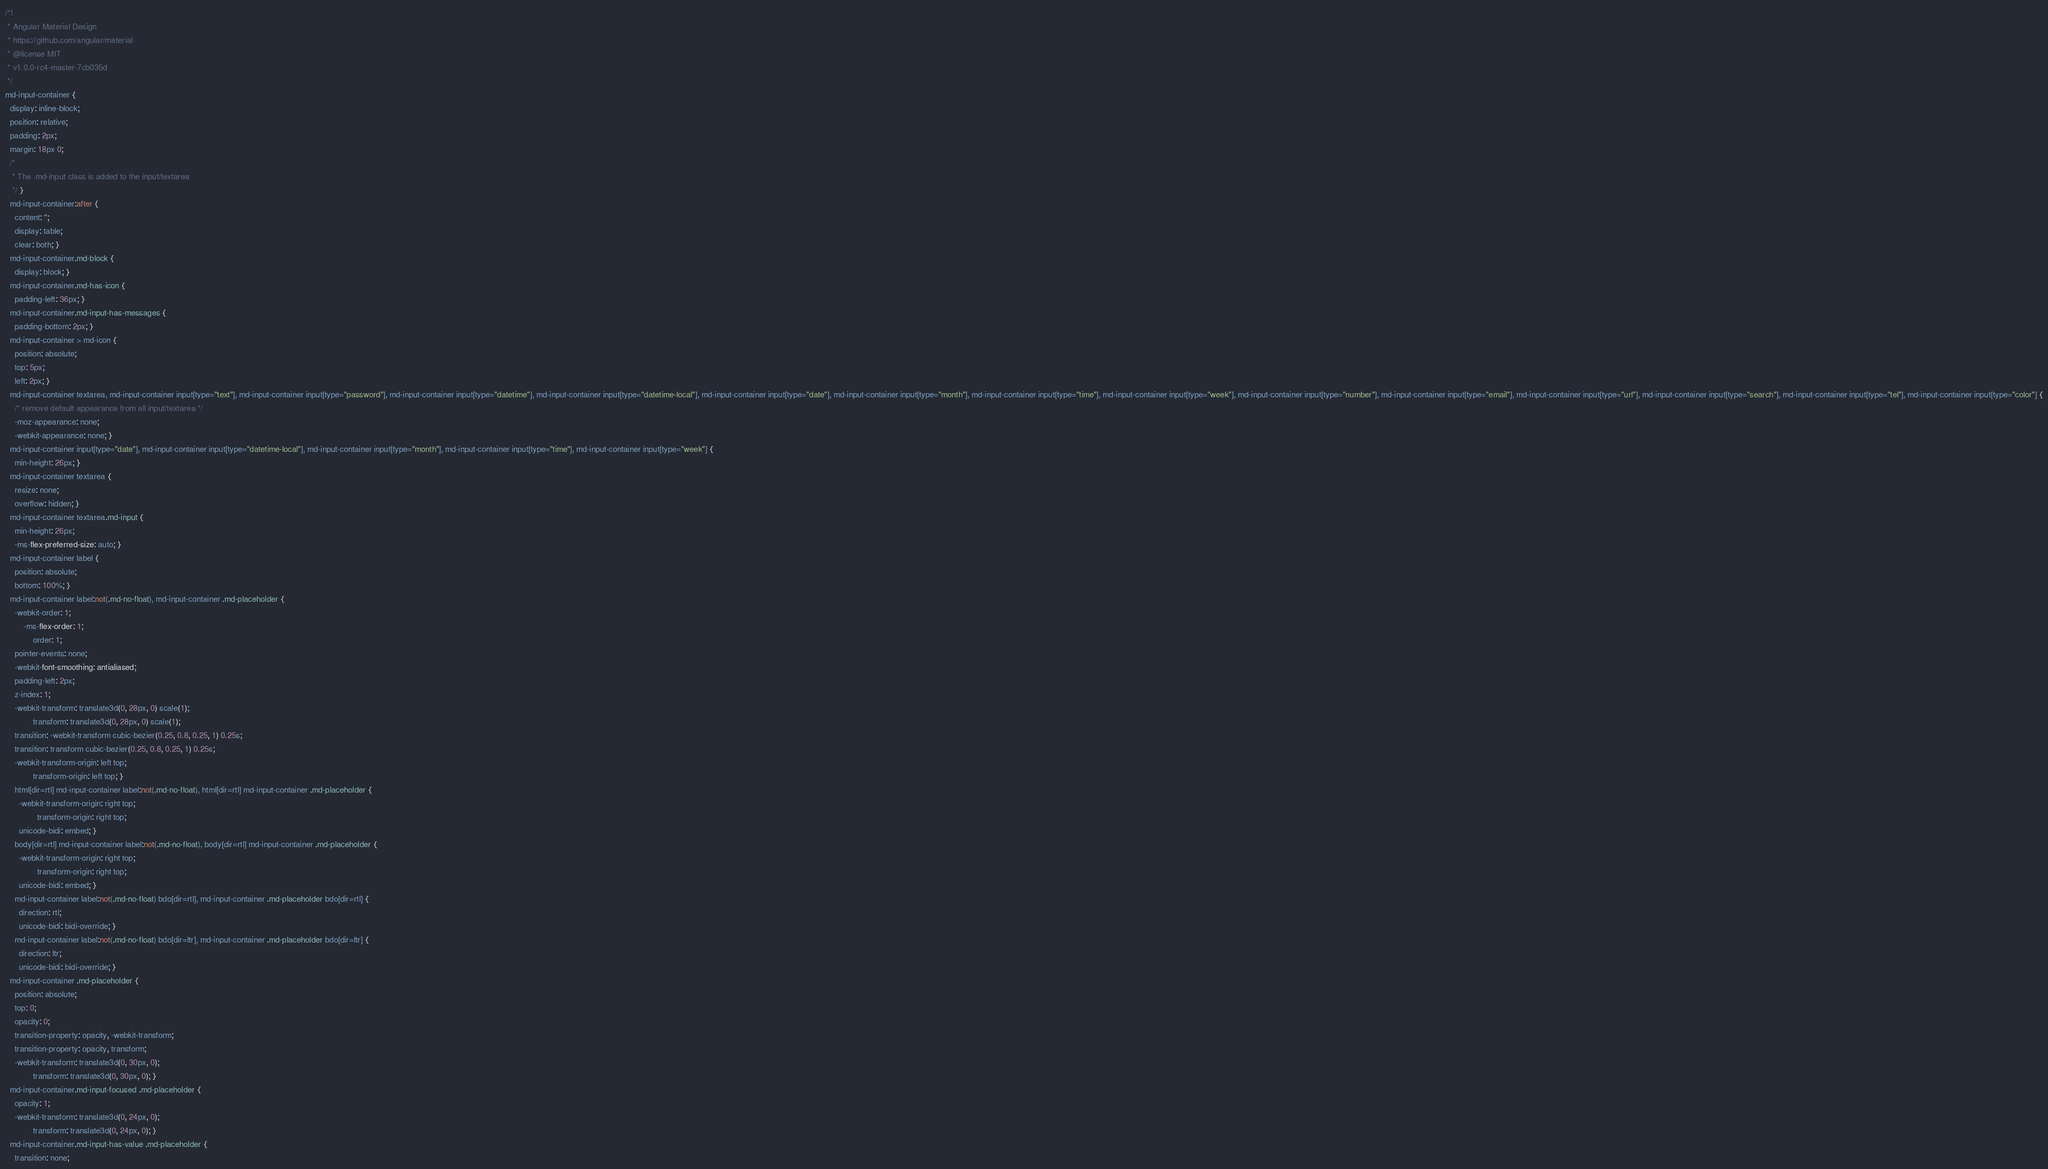<code> <loc_0><loc_0><loc_500><loc_500><_CSS_>/*!
 * Angular Material Design
 * https://github.com/angular/material
 * @license MIT
 * v1.0.0-rc4-master-7cb035d
 */
md-input-container {
  display: inline-block;
  position: relative;
  padding: 2px;
  margin: 18px 0;
  /*
   * The .md-input class is added to the input/textarea
   */ }
  md-input-container:after {
    content: '';
    display: table;
    clear: both; }
  md-input-container.md-block {
    display: block; }
  md-input-container.md-has-icon {
    padding-left: 36px; }
  md-input-container.md-input-has-messages {
    padding-bottom: 2px; }
  md-input-container > md-icon {
    position: absolute;
    top: 5px;
    left: 2px; }
  md-input-container textarea, md-input-container input[type="text"], md-input-container input[type="password"], md-input-container input[type="datetime"], md-input-container input[type="datetime-local"], md-input-container input[type="date"], md-input-container input[type="month"], md-input-container input[type="time"], md-input-container input[type="week"], md-input-container input[type="number"], md-input-container input[type="email"], md-input-container input[type="url"], md-input-container input[type="search"], md-input-container input[type="tel"], md-input-container input[type="color"] {
    /* remove default appearance from all input/textarea */
    -moz-appearance: none;
    -webkit-appearance: none; }
  md-input-container input[type="date"], md-input-container input[type="datetime-local"], md-input-container input[type="month"], md-input-container input[type="time"], md-input-container input[type="week"] {
    min-height: 26px; }
  md-input-container textarea {
    resize: none;
    overflow: hidden; }
  md-input-container textarea.md-input {
    min-height: 26px;
    -ms-flex-preferred-size: auto; }
  md-input-container label {
    position: absolute;
    bottom: 100%; }
  md-input-container label:not(.md-no-float), md-input-container .md-placeholder {
    -webkit-order: 1;
        -ms-flex-order: 1;
            order: 1;
    pointer-events: none;
    -webkit-font-smoothing: antialiased;
    padding-left: 2px;
    z-index: 1;
    -webkit-transform: translate3d(0, 28px, 0) scale(1);
            transform: translate3d(0, 28px, 0) scale(1);
    transition: -webkit-transform cubic-bezier(0.25, 0.8, 0.25, 1) 0.25s;
    transition: transform cubic-bezier(0.25, 0.8, 0.25, 1) 0.25s;
    -webkit-transform-origin: left top;
            transform-origin: left top; }
    html[dir=rtl] md-input-container label:not(.md-no-float), html[dir=rtl] md-input-container .md-placeholder {
      -webkit-transform-origin: right top;
              transform-origin: right top;
      unicode-bidi: embed; }
    body[dir=rtl] md-input-container label:not(.md-no-float), body[dir=rtl] md-input-container .md-placeholder {
      -webkit-transform-origin: right top;
              transform-origin: right top;
      unicode-bidi: embed; }
    md-input-container label:not(.md-no-float) bdo[dir=rtl], md-input-container .md-placeholder bdo[dir=rtl] {
      direction: rtl;
      unicode-bidi: bidi-override; }
    md-input-container label:not(.md-no-float) bdo[dir=ltr], md-input-container .md-placeholder bdo[dir=ltr] {
      direction: ltr;
      unicode-bidi: bidi-override; }
  md-input-container .md-placeholder {
    position: absolute;
    top: 0;
    opacity: 0;
    transition-property: opacity, -webkit-transform;
    transition-property: opacity, transform;
    -webkit-transform: translate3d(0, 30px, 0);
            transform: translate3d(0, 30px, 0); }
  md-input-container.md-input-focused .md-placeholder {
    opacity: 1;
    -webkit-transform: translate3d(0, 24px, 0);
            transform: translate3d(0, 24px, 0); }
  md-input-container.md-input-has-value .md-placeholder {
    transition: none;</code> 